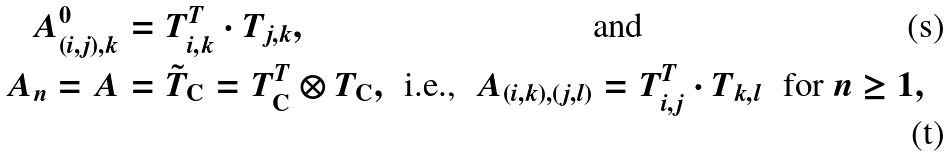Convert formula to latex. <formula><loc_0><loc_0><loc_500><loc_500>A ^ { 0 } _ { ( i , j ) , k } & = T _ { i , k } ^ { T } \cdot T _ { j , k } , & & & & \text {and} & & \\ A _ { n } = A & = \tilde { T } _ { \mathrm C } = T _ { \mathrm C } ^ { T } \otimes T _ { \mathrm C } , & & \text {i.e.,} & A _ { ( i , k ) , ( j , l ) } & = T _ { i , j } ^ { T } \cdot T _ { k , l } & & \text {for $n \geq 1$} ,</formula> 